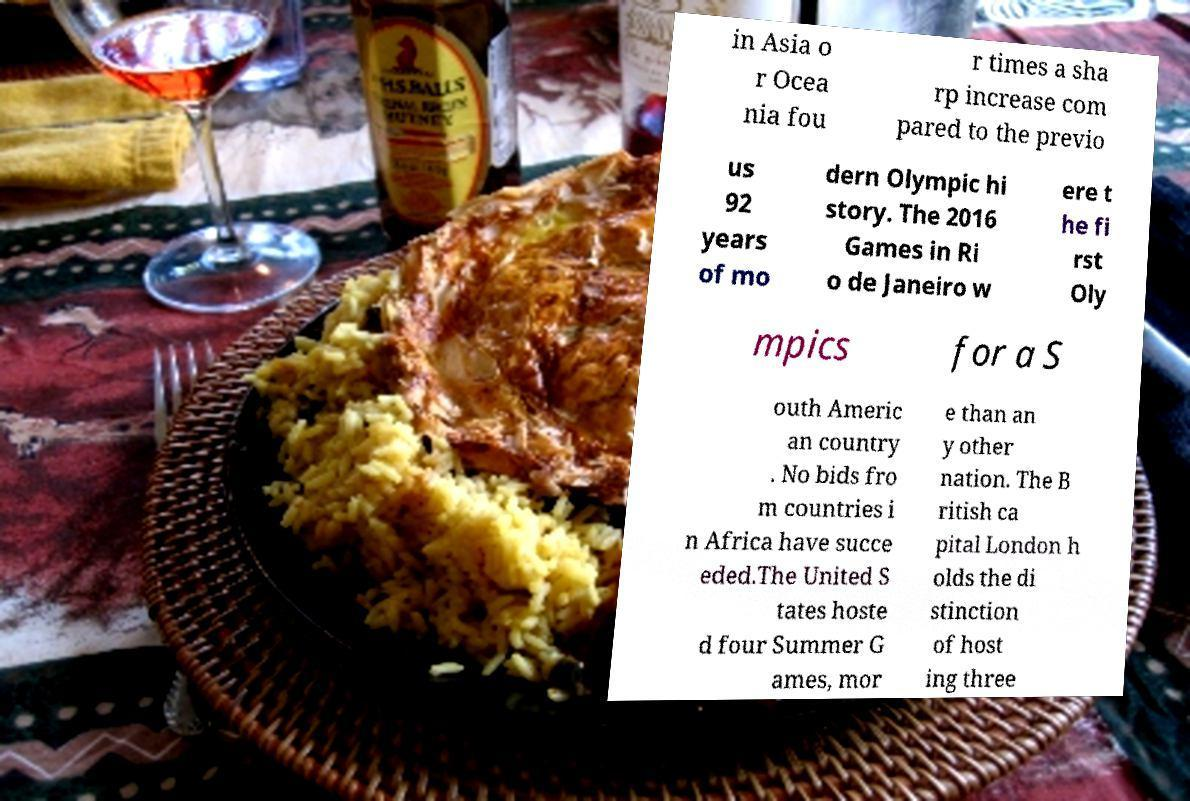Can you accurately transcribe the text from the provided image for me? in Asia o r Ocea nia fou r times a sha rp increase com pared to the previo us 92 years of mo dern Olympic hi story. The 2016 Games in Ri o de Janeiro w ere t he fi rst Oly mpics for a S outh Americ an country . No bids fro m countries i n Africa have succe eded.The United S tates hoste d four Summer G ames, mor e than an y other nation. The B ritish ca pital London h olds the di stinction of host ing three 